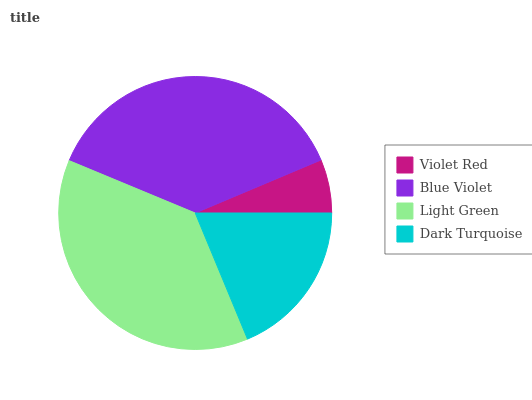Is Violet Red the minimum?
Answer yes or no. Yes. Is Light Green the maximum?
Answer yes or no. Yes. Is Blue Violet the minimum?
Answer yes or no. No. Is Blue Violet the maximum?
Answer yes or no. No. Is Blue Violet greater than Violet Red?
Answer yes or no. Yes. Is Violet Red less than Blue Violet?
Answer yes or no. Yes. Is Violet Red greater than Blue Violet?
Answer yes or no. No. Is Blue Violet less than Violet Red?
Answer yes or no. No. Is Blue Violet the high median?
Answer yes or no. Yes. Is Dark Turquoise the low median?
Answer yes or no. Yes. Is Dark Turquoise the high median?
Answer yes or no. No. Is Light Green the low median?
Answer yes or no. No. 